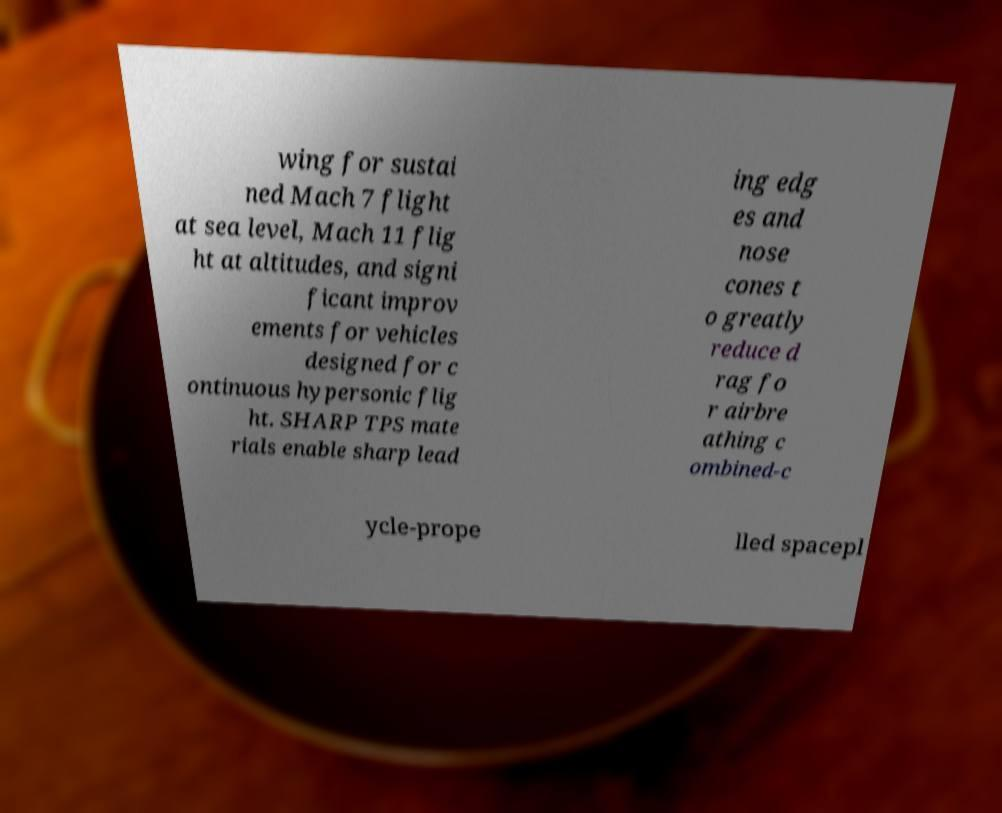Can you accurately transcribe the text from the provided image for me? wing for sustai ned Mach 7 flight at sea level, Mach 11 flig ht at altitudes, and signi ficant improv ements for vehicles designed for c ontinuous hypersonic flig ht. SHARP TPS mate rials enable sharp lead ing edg es and nose cones t o greatly reduce d rag fo r airbre athing c ombined-c ycle-prope lled spacepl 